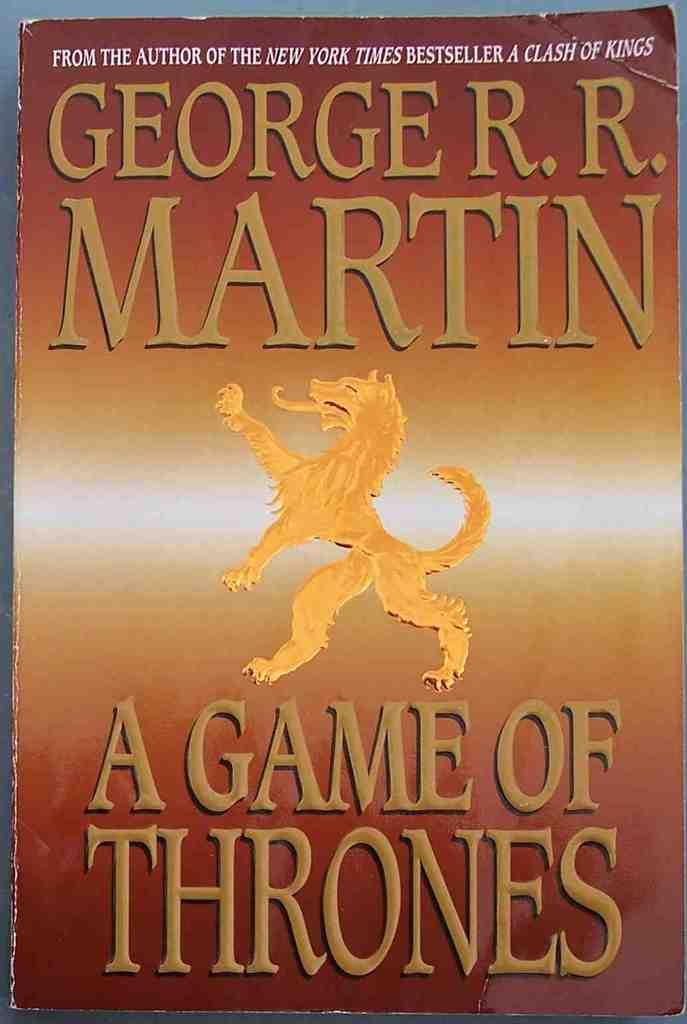<image>
Summarize the visual content of the image. George R. R. Martin is the author of "A Game of Thrones". 